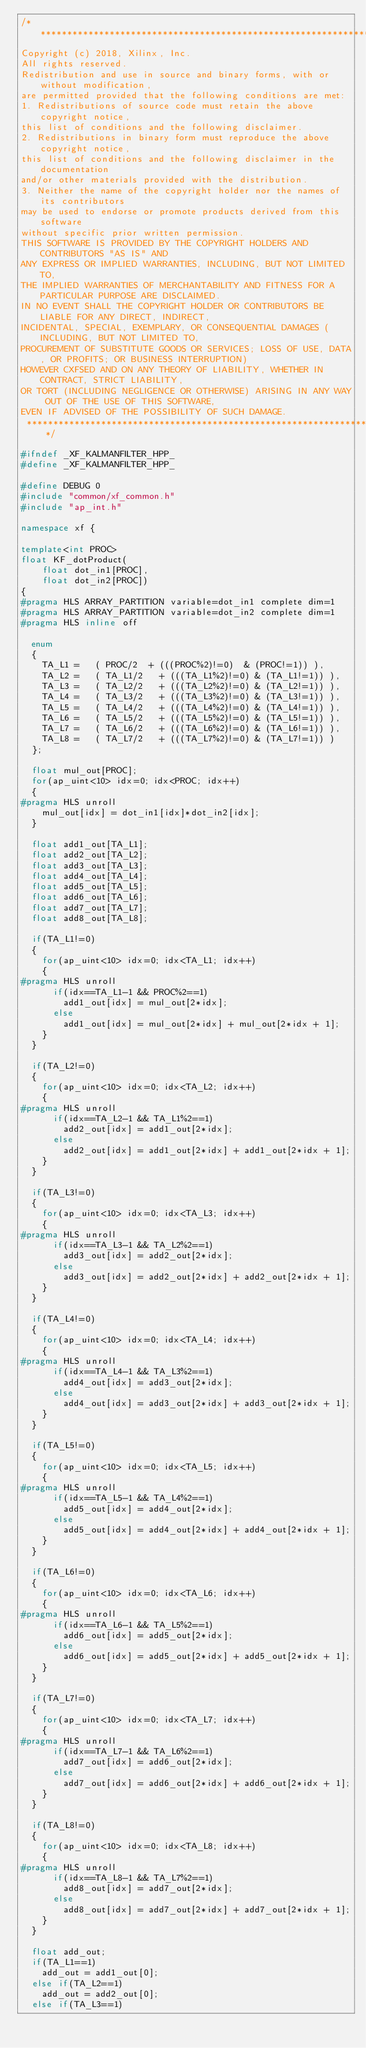<code> <loc_0><loc_0><loc_500><loc_500><_C++_>/***************************************************************************
Copyright (c) 2018, Xilinx, Inc.
All rights reserved.
Redistribution and use in source and binary forms, with or without modification,
are permitted provided that the following conditions are met:
1. Redistributions of source code must retain the above copyright notice,
this list of conditions and the following disclaimer.
2. Redistributions in binary form must reproduce the above copyright notice,
this list of conditions and the following disclaimer in the documentation
and/or other materials provided with the distribution.
3. Neither the name of the copyright holder nor the names of its contributors
may be used to endorse or promote products derived from this software
without specific prior written permission.
THIS SOFTWARE IS PROVIDED BY THE COPYRIGHT HOLDERS AND CONTRIBUTORS "AS IS" AND
ANY EXPRESS OR IMPLIED WARRANTIES, INCLUDING, BUT NOT LIMITED TO,
THE IMPLIED WARRANTIES OF MERCHANTABILITY AND FITNESS FOR A PARTICULAR PURPOSE ARE DISCLAIMED.
IN NO EVENT SHALL THE COPYRIGHT HOLDER OR CONTRIBUTORS BE LIABLE FOR ANY DIRECT, INDIRECT,
INCIDENTAL, SPECIAL, EXEMPLARY, OR CONSEQUENTIAL DAMAGES (INCLUDING, BUT NOT LIMITED TO,
PROCUREMENT OF SUBSTITUTE GOODS OR SERVICES; LOSS OF USE, DATA, OR PROFITS; OR BUSINESS INTERRUPTION)
HOWEVER CXFSED AND ON ANY THEORY OF LIABILITY, WHETHER IN CONTRACT, STRICT LIABILITY,
OR TORT (INCLUDING NEGLIGENCE OR OTHERWISE) ARISING IN ANY WAY OUT OF THE USE OF THIS SOFTWARE,
EVEN IF ADVISED OF THE POSSIBILITY OF SUCH DAMAGE.
 ***************************************************************************/

#ifndef _XF_KALMANFILTER_HPP_
#define _XF_KALMANFILTER_HPP_

#define DEBUG 0
#include "common/xf_common.h"
#include "ap_int.h"

namespace xf {

template<int PROC>
float KF_dotProduct(
		float dot_in1[PROC],
		float dot_in2[PROC])
{
#pragma HLS ARRAY_PARTITION variable=dot_in1 complete dim=1
#pragma HLS ARRAY_PARTITION variable=dot_in2 complete dim=1
#pragma HLS inline off

	enum
	{
		TA_L1 = 	( PROC/2 	+ (((PROC%2)!=0)  & (PROC!=1)) ),
		TA_L2 = 	( TA_L1/2 	+ (((TA_L1%2)!=0) & (TA_L1!=1)) ),
		TA_L3 = 	( TA_L2/2 	+ (((TA_L2%2)!=0) & (TA_L2!=1)) ),
		TA_L4 = 	( TA_L3/2 	+ (((TA_L3%2)!=0) & (TA_L3!=1)) ),
		TA_L5 = 	( TA_L4/2 	+ (((TA_L4%2)!=0) & (TA_L4!=1)) ),
		TA_L6 = 	( TA_L5/2 	+ (((TA_L5%2)!=0) & (TA_L5!=1)) ),
		TA_L7 = 	( TA_L6/2 	+ (((TA_L6%2)!=0) & (TA_L6!=1)) ),
		TA_L8 = 	( TA_L7/2 	+ (((TA_L7%2)!=0) & (TA_L7!=1)) )
	};

	float mul_out[PROC];
	for(ap_uint<10> idx=0; idx<PROC; idx++)
	{
#pragma HLS unroll
		mul_out[idx] = dot_in1[idx]*dot_in2[idx];
	}

	float add1_out[TA_L1];
	float add2_out[TA_L2];
	float add3_out[TA_L3];
	float add4_out[TA_L4];
	float add5_out[TA_L5];
	float add6_out[TA_L6];
	float add7_out[TA_L7];
	float add8_out[TA_L8];

	if(TA_L1!=0)
	{
		for(ap_uint<10> idx=0; idx<TA_L1; idx++)
		{
#pragma HLS unroll
			if(idx==TA_L1-1 && PROC%2==1)
				add1_out[idx] = mul_out[2*idx];
			else
				add1_out[idx] = mul_out[2*idx] + mul_out[2*idx + 1];
		}
	}

	if(TA_L2!=0)
	{
		for(ap_uint<10> idx=0; idx<TA_L2; idx++)
		{
#pragma HLS unroll
			if(idx==TA_L2-1 && TA_L1%2==1)
				add2_out[idx] = add1_out[2*idx];
			else
				add2_out[idx] = add1_out[2*idx] + add1_out[2*idx + 1];
		}
	}

	if(TA_L3!=0)
	{
		for(ap_uint<10> idx=0; idx<TA_L3; idx++)
		{
#pragma HLS unroll
			if(idx==TA_L3-1 && TA_L2%2==1)
				add3_out[idx] = add2_out[2*idx];
			else
				add3_out[idx] = add2_out[2*idx] + add2_out[2*idx + 1];
		}
	}

	if(TA_L4!=0)
	{
		for(ap_uint<10> idx=0; idx<TA_L4; idx++)
		{
#pragma HLS unroll
			if(idx==TA_L4-1 && TA_L3%2==1)
				add4_out[idx] = add3_out[2*idx];
			else
				add4_out[idx] = add3_out[2*idx] + add3_out[2*idx + 1];
		}
	}

	if(TA_L5!=0)
	{
		for(ap_uint<10> idx=0; idx<TA_L5; idx++)
		{
#pragma HLS unroll
			if(idx==TA_L5-1 && TA_L4%2==1)
				add5_out[idx] = add4_out[2*idx];
			else
				add5_out[idx] = add4_out[2*idx] + add4_out[2*idx + 1];
		}
	}

	if(TA_L6!=0)
	{
		for(ap_uint<10> idx=0; idx<TA_L6; idx++)
		{
#pragma HLS unroll
			if(idx==TA_L6-1 && TA_L5%2==1)
				add6_out[idx] = add5_out[2*idx];
			else
				add6_out[idx] = add5_out[2*idx] + add5_out[2*idx + 1];
		}
	}

	if(TA_L7!=0)
	{
		for(ap_uint<10> idx=0; idx<TA_L7; idx++)
		{
#pragma HLS unroll
			if(idx==TA_L7-1 && TA_L6%2==1)
				add7_out[idx] = add6_out[2*idx];
			else
				add7_out[idx] = add6_out[2*idx] + add6_out[2*idx + 1];
		}
	}

	if(TA_L8!=0)
	{
		for(ap_uint<10> idx=0; idx<TA_L8; idx++)
		{
#pragma HLS unroll
			if(idx==TA_L8-1 && TA_L7%2==1)
				add8_out[idx] = add7_out[2*idx];
			else
				add8_out[idx] = add7_out[2*idx] + add7_out[2*idx + 1];
		}
	}

	float add_out;
	if(TA_L1==1)
		add_out = add1_out[0];
	else if(TA_L2==1)
		add_out = add2_out[0];
	else if(TA_L3==1)</code> 